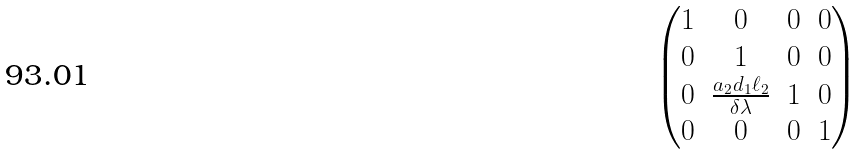<formula> <loc_0><loc_0><loc_500><loc_500>\begin{pmatrix} 1 & 0 & 0 & 0 \\ 0 & 1 & 0 & 0 \\ 0 & \frac { a _ { 2 } d _ { 1 } \ell _ { 2 } } { \delta \lambda } & 1 & 0 \\ 0 & 0 & 0 & 1 \end{pmatrix}</formula> 